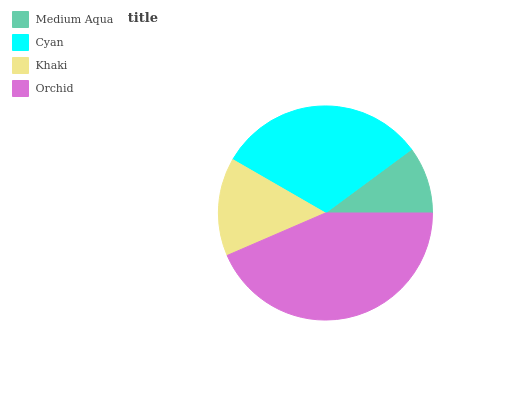Is Medium Aqua the minimum?
Answer yes or no. Yes. Is Orchid the maximum?
Answer yes or no. Yes. Is Cyan the minimum?
Answer yes or no. No. Is Cyan the maximum?
Answer yes or no. No. Is Cyan greater than Medium Aqua?
Answer yes or no. Yes. Is Medium Aqua less than Cyan?
Answer yes or no. Yes. Is Medium Aqua greater than Cyan?
Answer yes or no. No. Is Cyan less than Medium Aqua?
Answer yes or no. No. Is Cyan the high median?
Answer yes or no. Yes. Is Khaki the low median?
Answer yes or no. Yes. Is Khaki the high median?
Answer yes or no. No. Is Orchid the low median?
Answer yes or no. No. 